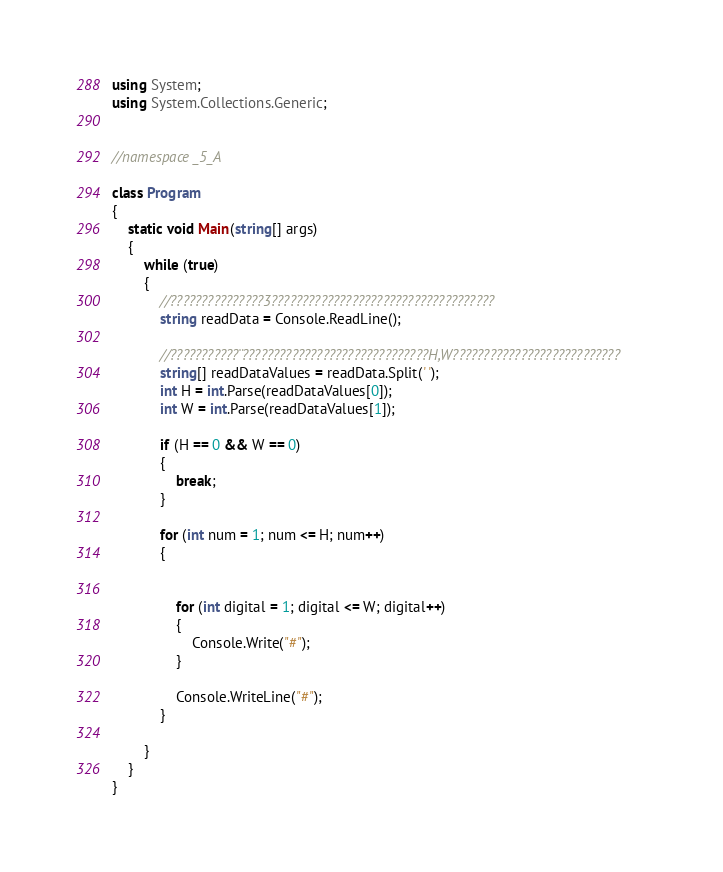<code> <loc_0><loc_0><loc_500><loc_500><_C#_>using System;
using System.Collections.Generic;


//namespace _5_A

class Program
{
    static void Main(string[] args)
    {
        while (true)
        {
            //???????????????3????????????????????????????????????
            string readData = Console.ReadLine();

            //???????????¨??????????????????????????????H,W???????????????????????????
            string[] readDataValues = readData.Split(' ');
            int H = int.Parse(readDataValues[0]);
            int W = int.Parse(readDataValues[1]);

            if (H == 0 && W == 0)
            {
                break;
            }

            for (int num = 1; num <= H; num++)
            {


                for (int digital = 1; digital <= W; digital++)
                {
                    Console.Write("#");
                }

                Console.WriteLine("#");
            }

        }
    }
}</code> 